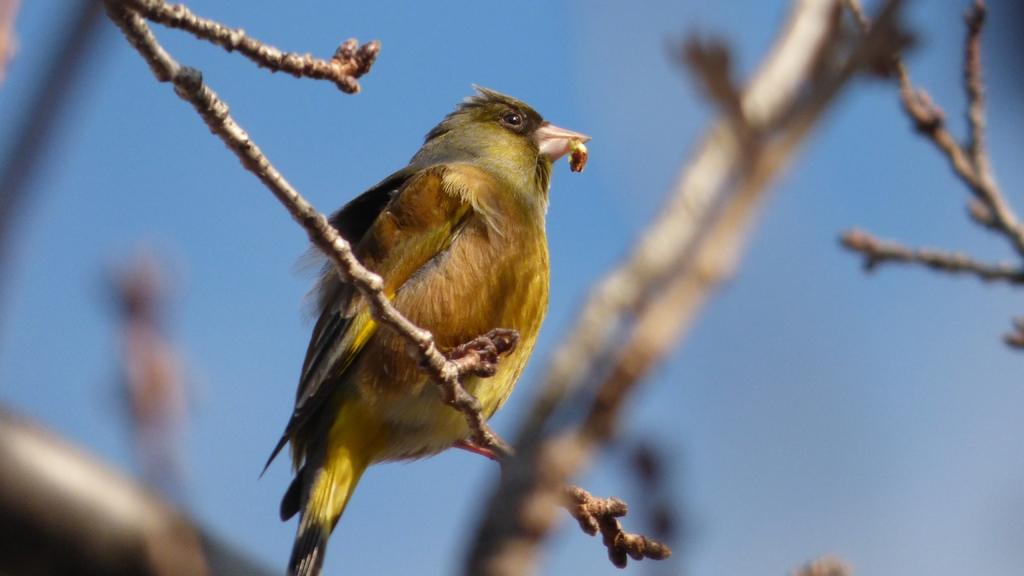What type of animal is in the image? There is a bird in the image. What color is the bird? The bird is yellow in color. Where is the bird located in the image? The bird is on a tree branch. What type of wool is the bird using to keep warm in the image? There is no wool present in the image, and the bird's warmth is not mentioned in the facts provided. 